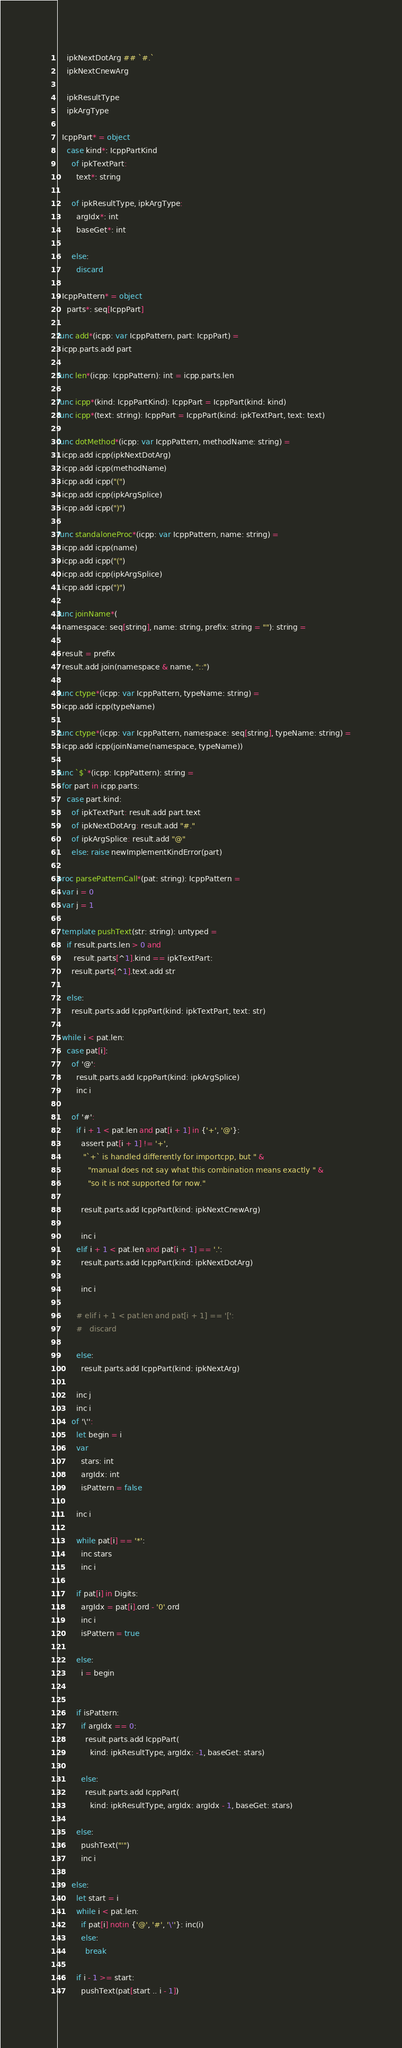Convert code to text. <code><loc_0><loc_0><loc_500><loc_500><_Nim_>    ipkNextDotArg ## `#.`
    ipkNextCnewArg

    ipkResultType
    ipkArgType

  IcppPart* = object
    case kind*: IcppPartKind
      of ipkTextPart:
        text*: string

      of ipkResultType, ipkArgType:
        argIdx*: int
        baseGet*: int

      else:
        discard

  IcppPattern* = object
    parts*: seq[IcppPart]

func add*(icpp: var IcppPattern, part: IcppPart) =
  icpp.parts.add part

func len*(icpp: IcppPattern): int = icpp.parts.len

func icpp*(kind: IcppPartKind): IcppPart = IcppPart(kind: kind)
func icpp*(text: string): IcppPart = IcppPart(kind: ipkTextPart, text: text)

func dotMethod*(icpp: var IcppPattern, methodName: string) =
  icpp.add icpp(ipkNextDotArg)
  icpp.add icpp(methodName)
  icpp.add icpp("(")
  icpp.add icpp(ipkArgSplice)
  icpp.add icpp(")")

func standaloneProc*(icpp: var IcppPattern, name: string) =
  icpp.add icpp(name)
  icpp.add icpp("(")
  icpp.add icpp(ipkArgSplice)
  icpp.add icpp(")")

func joinName*(
  namespace: seq[string], name: string, prefix: string = ""): string =

  result = prefix
  result.add join(namespace & name, "::")

func ctype*(icpp: var IcppPattern, typeName: string) =
  icpp.add icpp(typeName)

func ctype*(icpp: var IcppPattern, namespace: seq[string], typeName: string) =
  icpp.add icpp(joinName(namespace, typeName))

func `$`*(icpp: IcppPattern): string =
  for part in icpp.parts:
    case part.kind:
      of ipkTextPart: result.add part.text
      of ipkNextDotArg: result.add "#."
      of ipkArgSplice: result.add "@"
      else: raise newImplementKindError(part)

proc parsePatternCall*(pat: string): IcppPattern =
  var i = 0
  var j = 1

  template pushText(str: string): untyped =
    if result.parts.len > 0 and
       result.parts[^1].kind == ipkTextPart:
      result.parts[^1].text.add str

    else:
      result.parts.add IcppPart(kind: ipkTextPart, text: str)

  while i < pat.len:
    case pat[i]:
      of '@':
        result.parts.add IcppPart(kind: ipkArgSplice)
        inc i

      of '#':
        if i + 1 < pat.len and pat[i + 1] in {'+', '@'}:
          assert pat[i + 1] != '+',
           "`+` is handled differently for importcpp, but " &
             "manual does not say what this combination means exactly " &
             "so it is not supported for now."

          result.parts.add IcppPart(kind: ipkNextCnewArg)

          inc i
        elif i + 1 < pat.len and pat[i + 1] == '.':
          result.parts.add IcppPart(kind: ipkNextDotArg)

          inc i

        # elif i + 1 < pat.len and pat[i + 1] == '[':
        #   discard

        else:
          result.parts.add IcppPart(kind: ipkNextArg)

        inc j
        inc i
      of '\'':
        let begin = i
        var
          stars: int
          argIdx: int
          isPattern = false

        inc i

        while pat[i] == '*':
          inc stars
          inc i

        if pat[i] in Digits:
          argIdx = pat[i].ord - '0'.ord
          inc i
          isPattern = true

        else:
          i = begin


        if isPattern:
          if argIdx == 0:
            result.parts.add IcppPart(
              kind: ipkResultType, argIdx: -1, baseGet: stars)

          else:
            result.parts.add IcppPart(
              kind: ipkResultType, argIdx: argIdx - 1, baseGet: stars)

        else:
          pushText("'")
          inc i

      else:
        let start = i
        while i < pat.len:
          if pat[i] notin {'@', '#', '\''}: inc(i)
          else:
            break

        if i - 1 >= start:
          pushText(pat[start .. i - 1])
</code> 